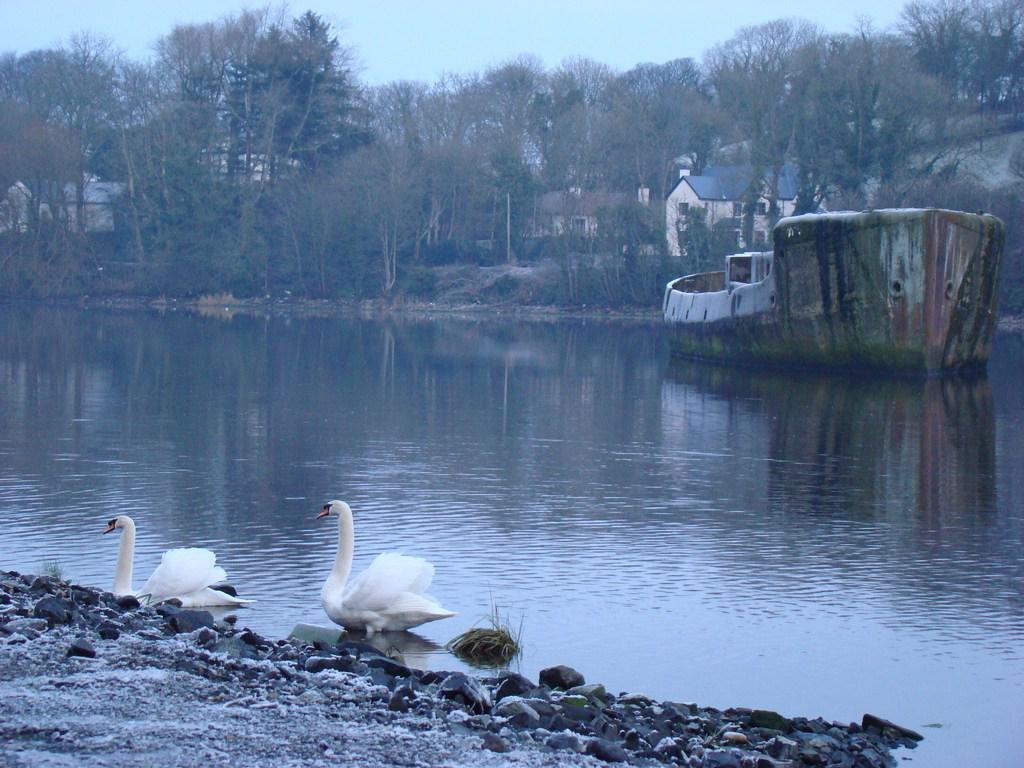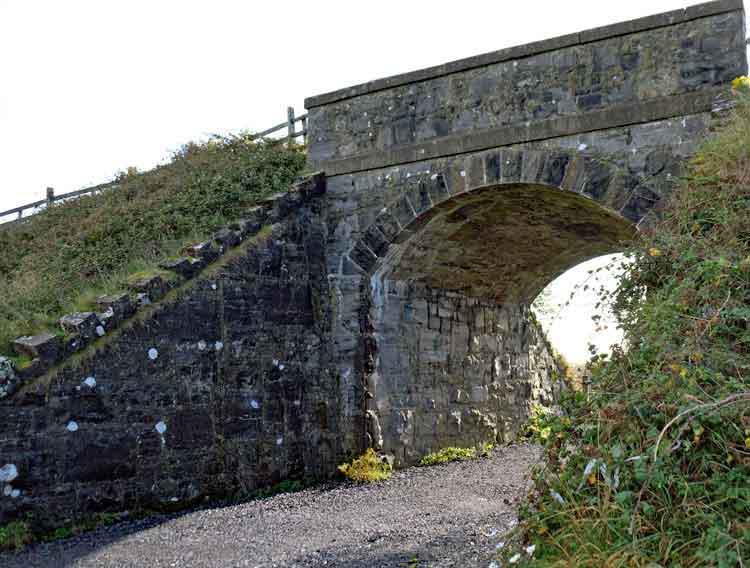The first image is the image on the left, the second image is the image on the right. Given the left and right images, does the statement "There is a castle with a broken tower in the image on the left." hold true? Answer yes or no. No. 